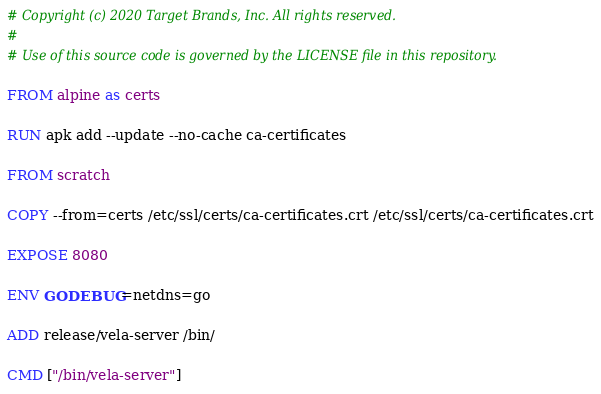Convert code to text. <code><loc_0><loc_0><loc_500><loc_500><_Dockerfile_># Copyright (c) 2020 Target Brands, Inc. All rights reserved.
#
# Use of this source code is governed by the LICENSE file in this repository.

FROM alpine as certs

RUN apk add --update --no-cache ca-certificates

FROM scratch

COPY --from=certs /etc/ssl/certs/ca-certificates.crt /etc/ssl/certs/ca-certificates.crt

EXPOSE 8080

ENV GODEBUG=netdns=go

ADD release/vela-server /bin/

CMD ["/bin/vela-server"]
</code> 